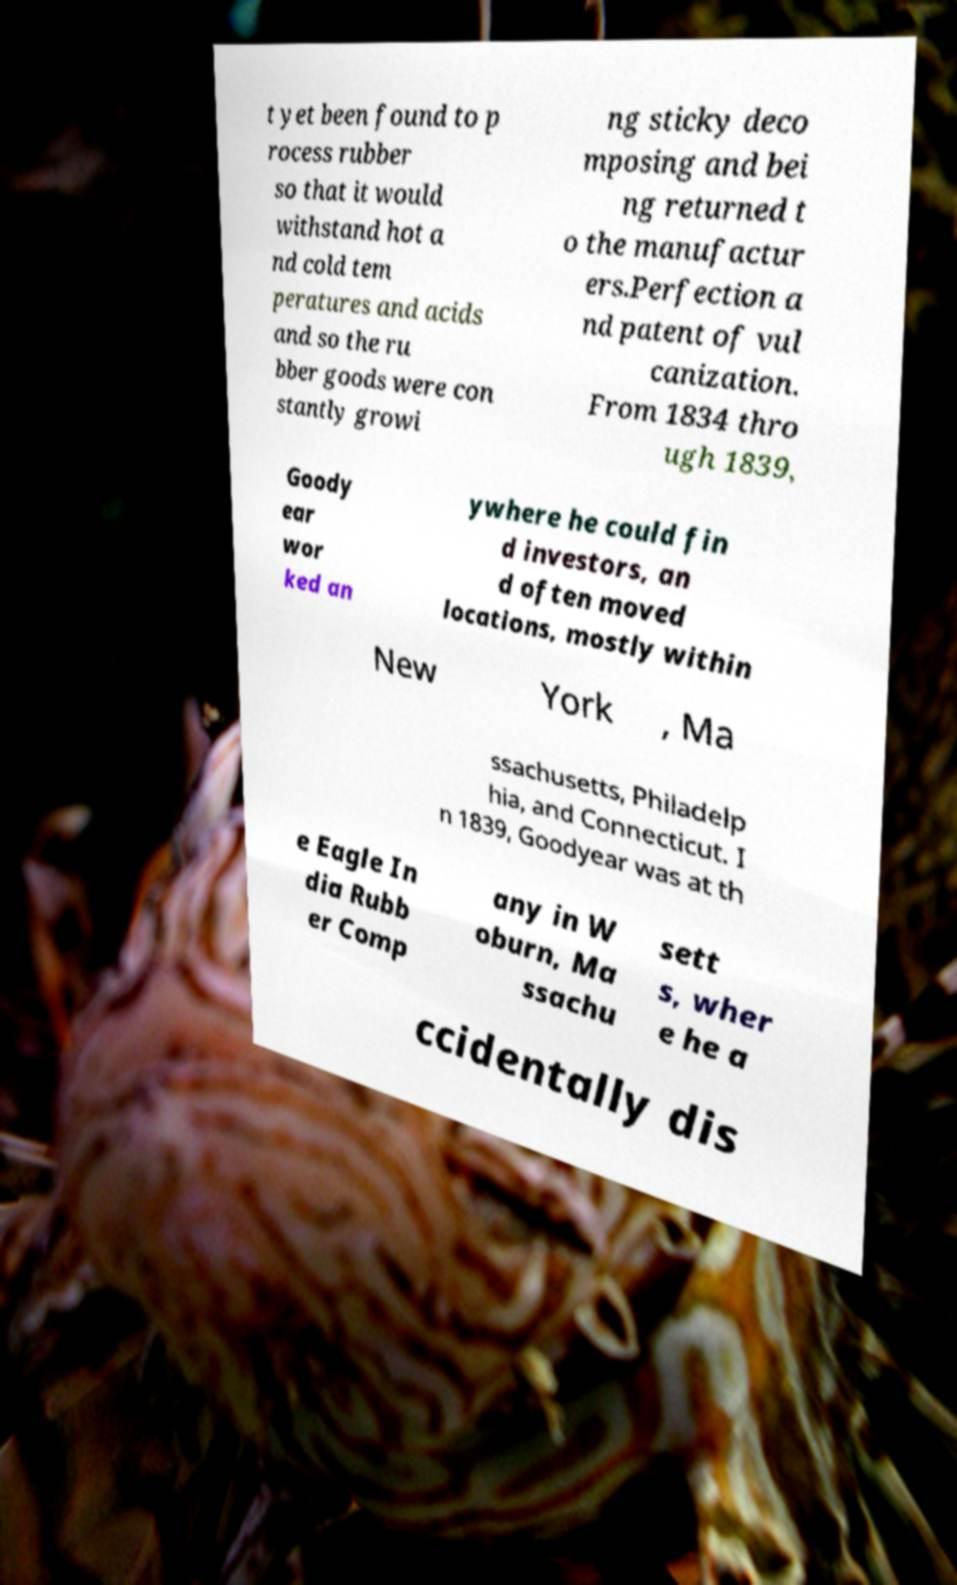Can you accurately transcribe the text from the provided image for me? t yet been found to p rocess rubber so that it would withstand hot a nd cold tem peratures and acids and so the ru bber goods were con stantly growi ng sticky deco mposing and bei ng returned t o the manufactur ers.Perfection a nd patent of vul canization. From 1834 thro ugh 1839, Goody ear wor ked an ywhere he could fin d investors, an d often moved locations, mostly within New York , Ma ssachusetts, Philadelp hia, and Connecticut. I n 1839, Goodyear was at th e Eagle In dia Rubb er Comp any in W oburn, Ma ssachu sett s, wher e he a ccidentally dis 